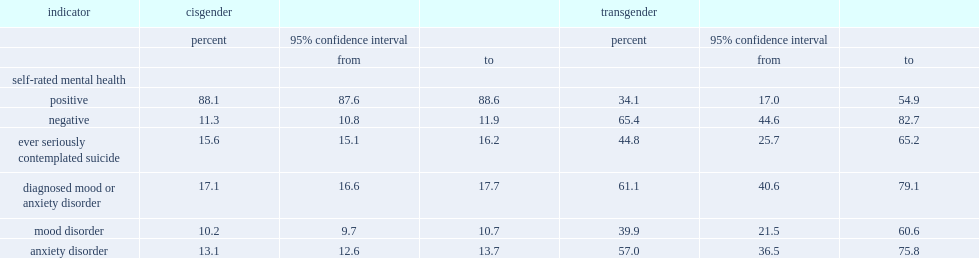What proportion of cisgender canadians has considered their mental health to be poor or fair? 11.3. Which group of people were much more likely to have a diagnosed mood or anxiety disorder? transgender canadians or cisgender canadians? Transgender. Which group of people were much more likely to have seriously contemplated suicide in their lifetimes? transgender canadians or cisgender canadians? Transgender. 